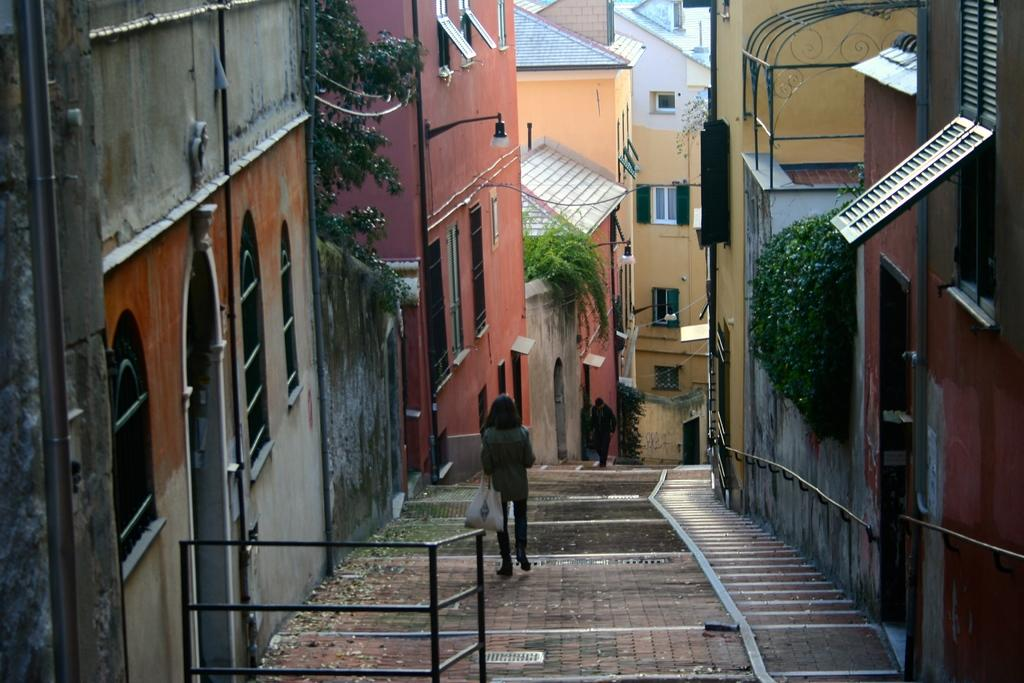What are the two people in the image doing? The two people in the image are walking. What can be seen in the distance behind the people? There are buildings and trees in the background of the image. Are there any artificial light sources visible in the image? Yes, lights are visible in the image. What type of yarn is being used to create the cart in the image? There is no yarn or cart present in the image. How many bikes are visible in the image? There are no bikes visible in the image. 